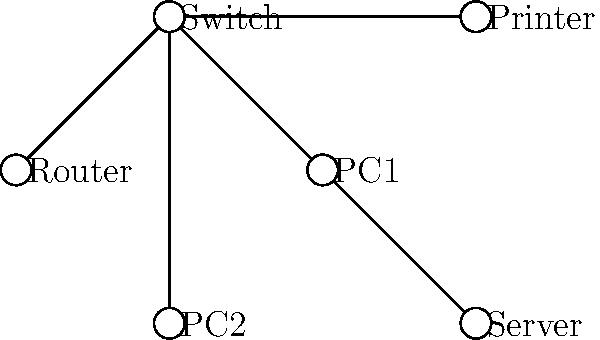As a customer excited about your favorite local business's digital transformation, you notice their new network setup. Which network topology does this infrastructure represent, and how does it benefit the small business's operations? Let's analyze the network topology step-by-step:

1. Central device: The diagram shows a central device (Switch) connected to all other devices.
2. Connections: All devices are connected to the central Switch, forming a radial pattern.
3. Topology identification: This arrangement represents a star topology.

Benefits of star topology for a small business:

1. Centralized management: Easy to add, remove, or troubleshoot devices from a central point.
2. Reliability: If one connection fails, it doesn't affect other devices.
3. Performance: Direct connections to the switch provide faster data transfer between devices.
4. Scalability: New devices can be easily added by connecting them to the central switch.
5. Cost-effective: Requires less cabling compared to some other topologies.

The star topology is ideal for small businesses because it offers a balance of performance, reliability, and ease of management, supporting their digital transformation efforts.
Answer: Star topology 